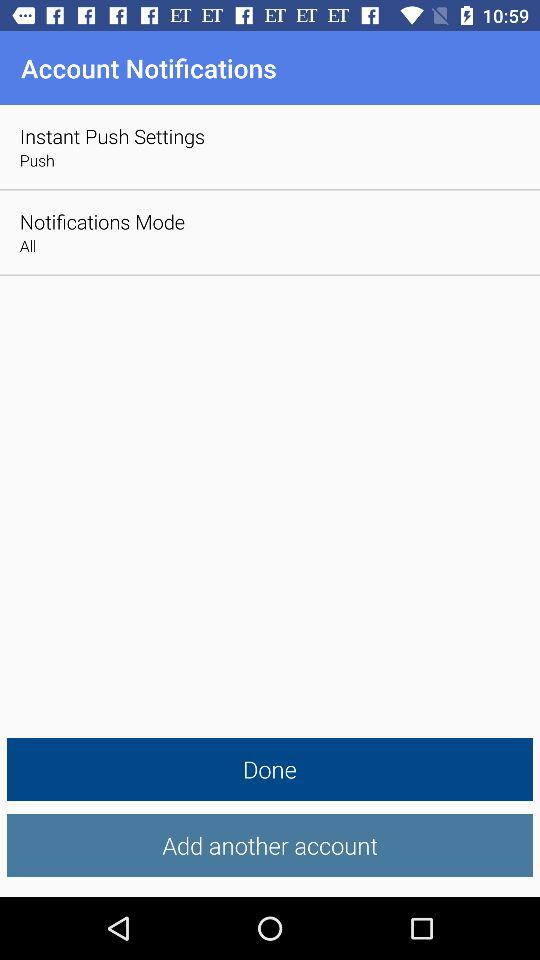Which option is selected in "Notifications Mode"? The selected option in "Notifications Mode" is "All". 